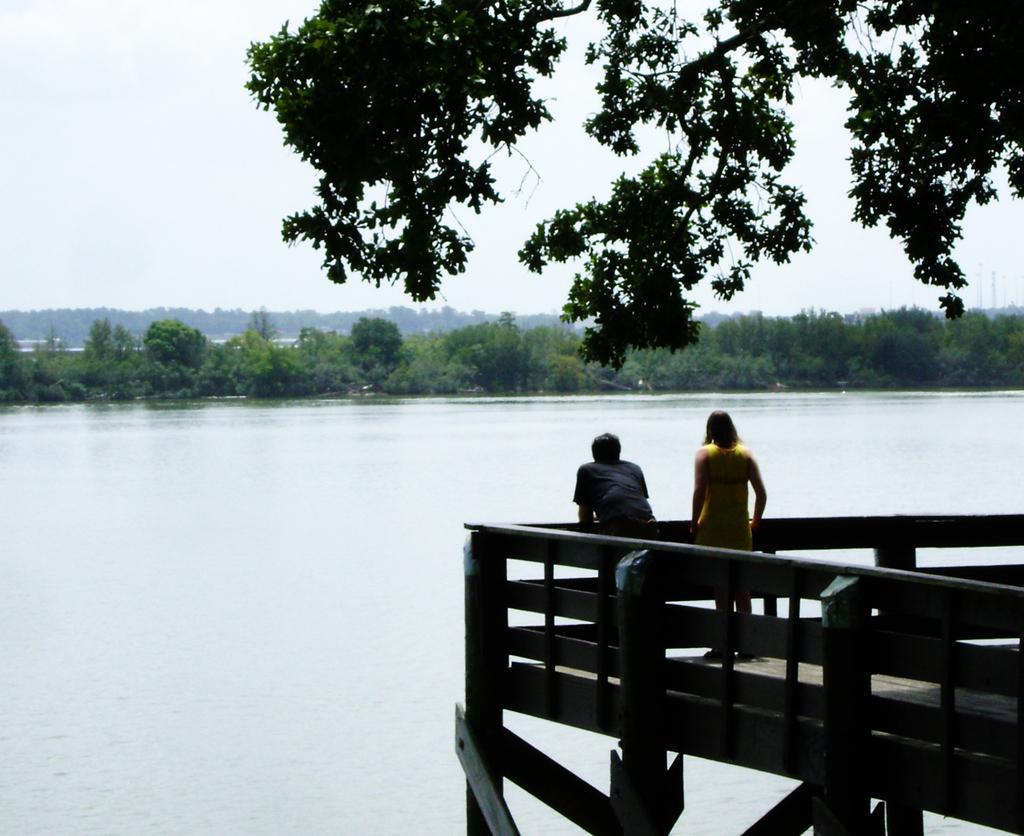Can you describe this image briefly? In this image there are two people standing on the bridge having a fence. There is a lake. Background there are trees. Right top there are branches having leaves. Top of the image there is sky. 